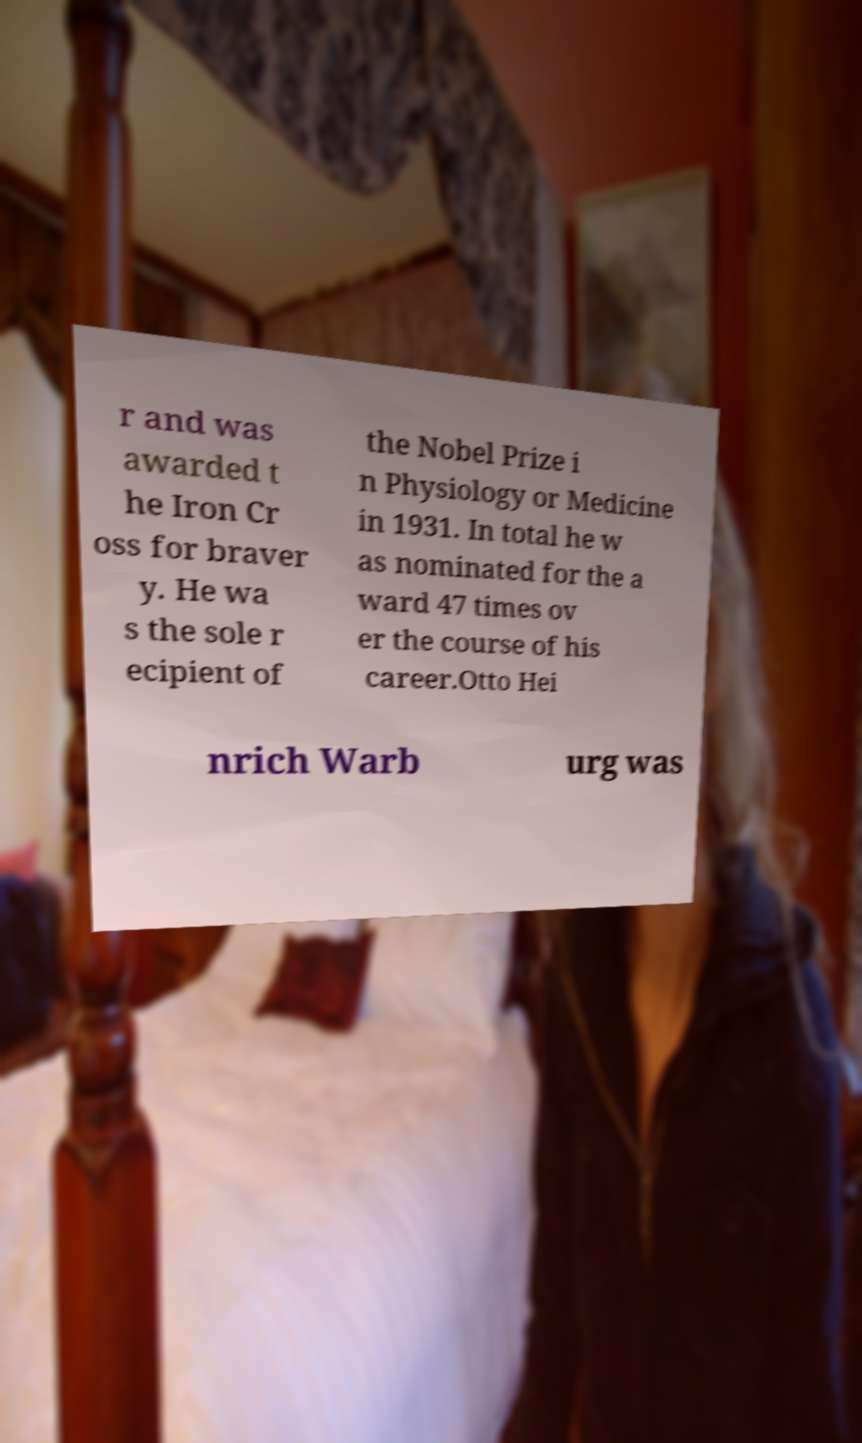Can you read and provide the text displayed in the image?This photo seems to have some interesting text. Can you extract and type it out for me? r and was awarded t he Iron Cr oss for braver y. He wa s the sole r ecipient of the Nobel Prize i n Physiology or Medicine in 1931. In total he w as nominated for the a ward 47 times ov er the course of his career.Otto Hei nrich Warb urg was 